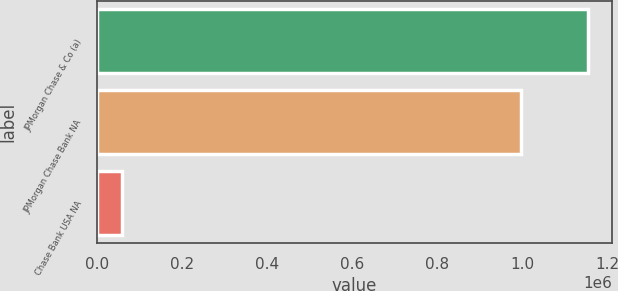<chart> <loc_0><loc_0><loc_500><loc_500><bar_chart><fcel>JPMorgan Chase & Co (a)<fcel>JPMorgan Chase Bank NA<fcel>Chase Bank USA NA<nl><fcel>1.15255e+06<fcel>995095<fcel>59882<nl></chart> 